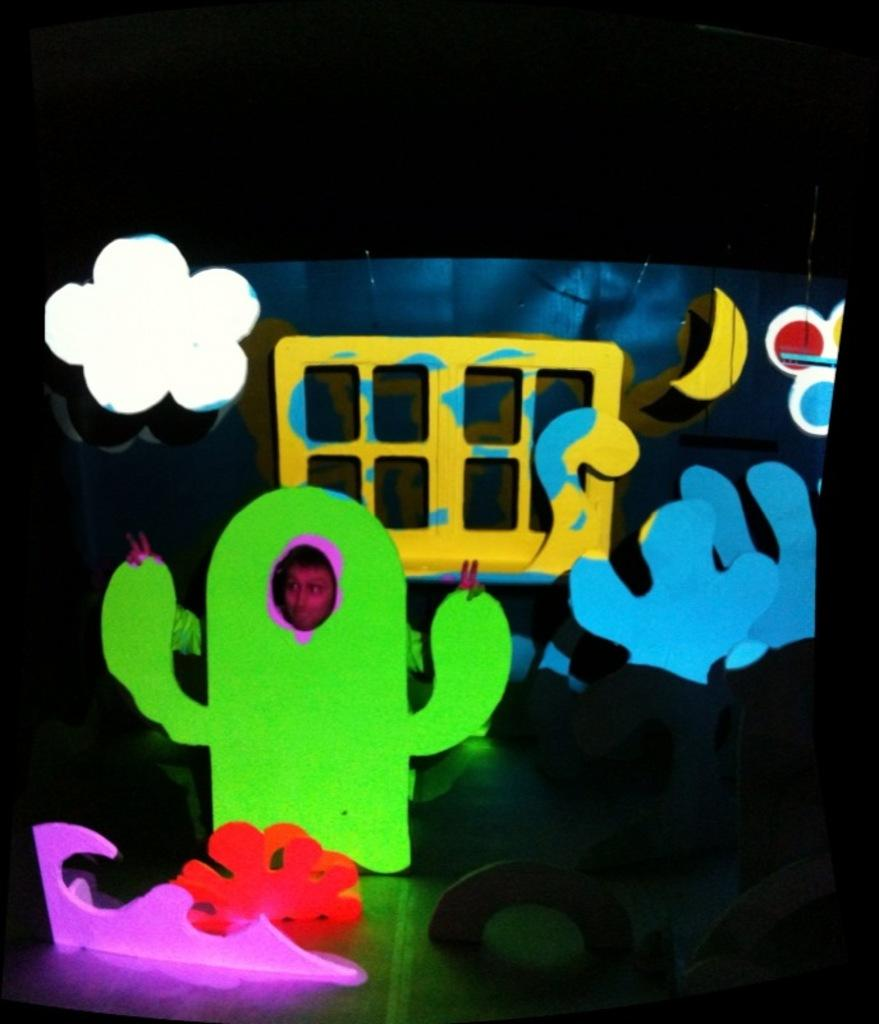Who is present in the image? There is a man in the image. What is the man wearing? The man is wearing a dress with a cactus plant design. What can be seen in the background of the image? There is a decorated stage in the background. How would you describe the lighting in the image? The background of the image is dark. What type of disease is the man suffering from in the image? There is no indication in the image that the man is suffering from any disease. How does the man use the comb in the image? There is no comb present in the image. 